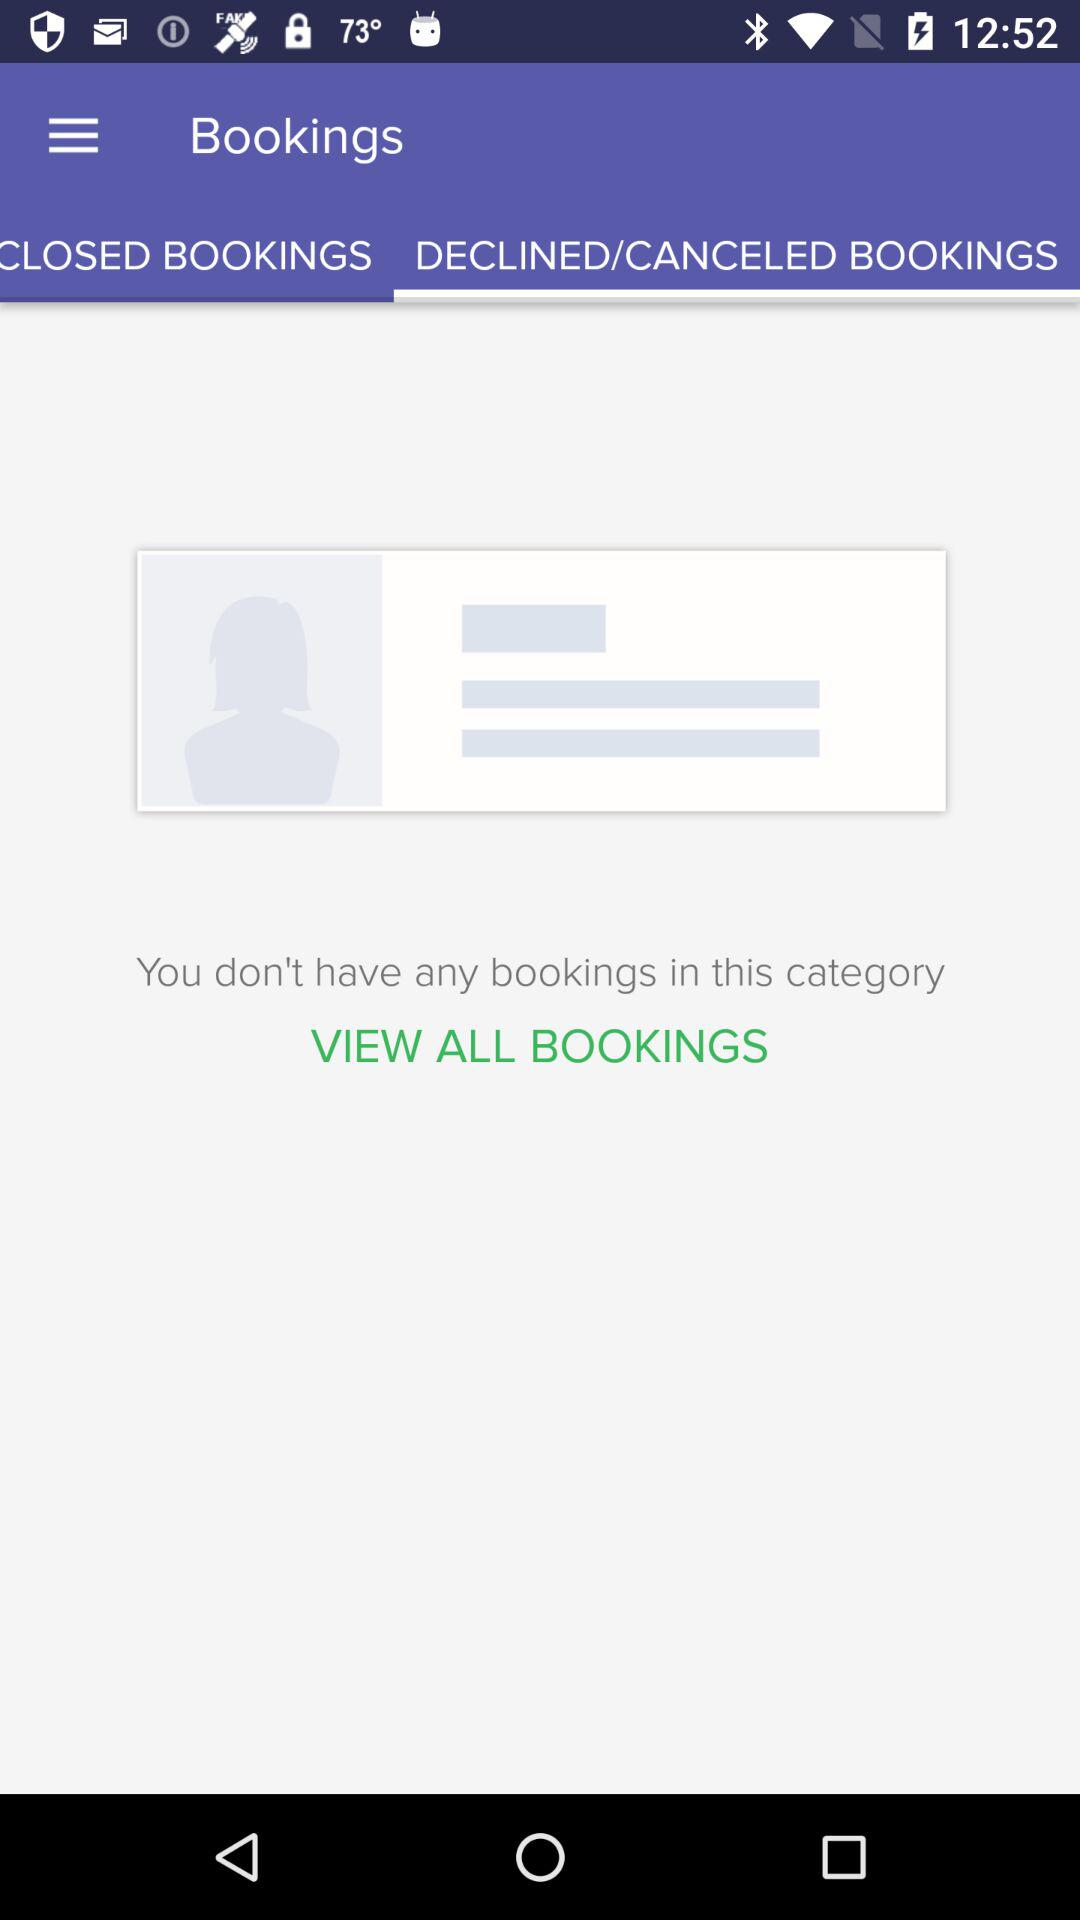How many closed bookings are there?
Answer the question using a single word or phrase. 0 